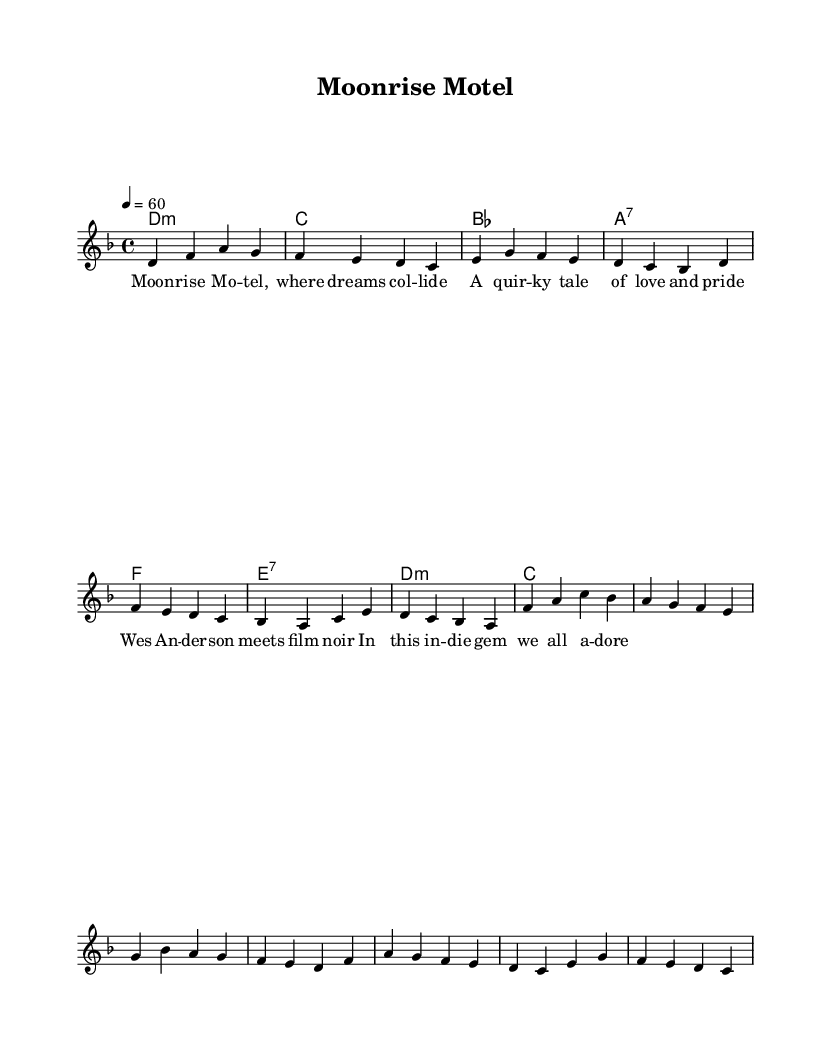What is the key signature of this music? The key signature is indicated at the beginning of the sheet music, and it shows two flats. This corresponds to B flat major or G minor as keys. However, since the melody primarily uses notes that fit within D minor, we conclude it is D minor.
Answer: D minor What is the time signature of this piece? The time signature is located at the beginning of the sheet music after the key signature, shown as a fraction. It reads four beats in a measure, indicated by 4 over 4.
Answer: 4/4 What is the tempo marking for this piece? The tempo is marked above the staff, indicated as a metronome marking. The value given is 60 beats per minute, suggesting a slow and steady pace.
Answer: 60 How many measures are there in the verse section? By counting the distinct segments of music notation and phrases assigned to the verse, we find that there are four measures in that part. Each separated segment represents one measure.
Answer: 4 Which chord is played on the first beat of the chorus? Looking at the rhythm and chord indicators within the score, the first chord for the chorus is labeled as F major, which is shown over the first note in that section.
Answer: F What type of song structure does this piece follow? By analyzing the layout of the sections labeled as verse and chorus, we observe a standard structure often used in ballads, known for alternating between these sections. This indicates a verse-chorus form commonly seen in Rhythm and blues music.
Answer: Verse-Chorus 